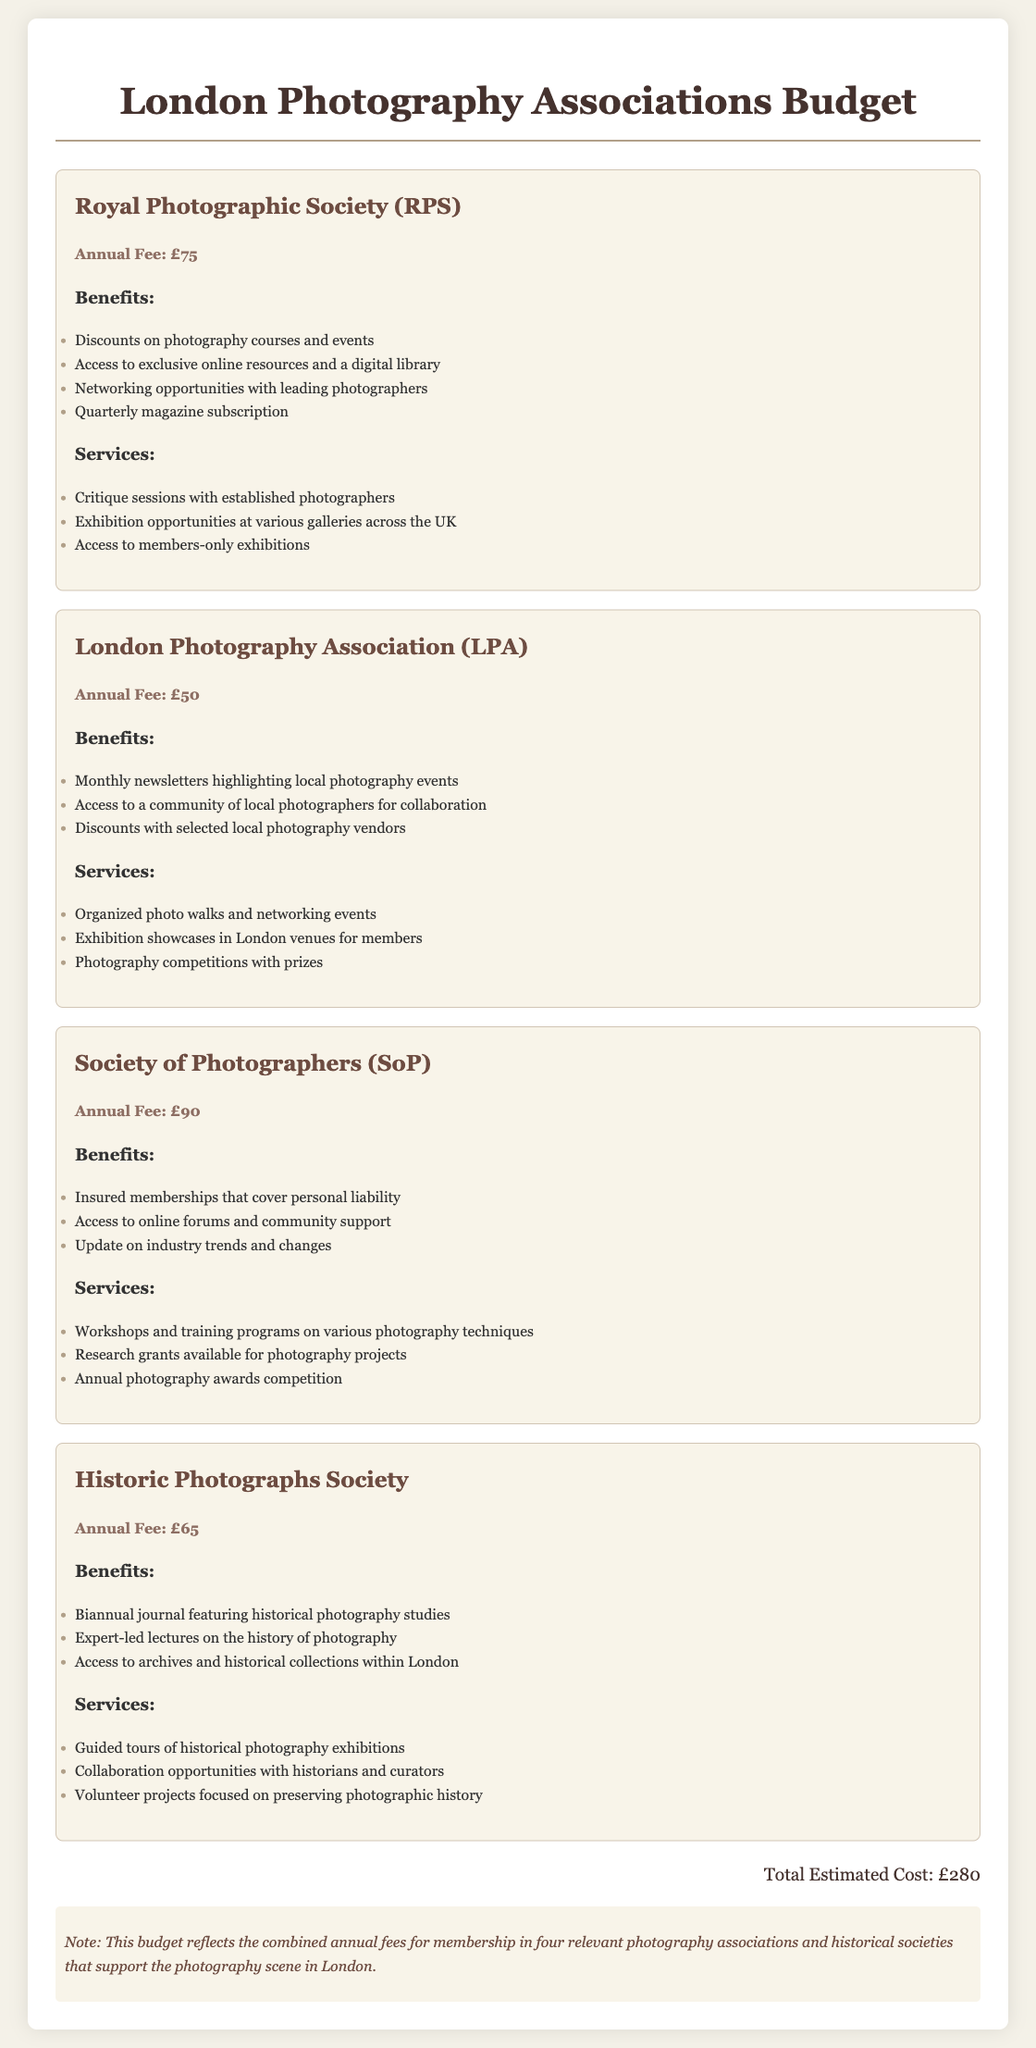What is the annual fee for the Royal Photographic Society? The document provides the annual fee for each association, which for the Royal Photographic Society is £75.
Answer: £75 What benefits does the London Photography Association offer? The benefits listed for the London Photography Association include monthly newsletters, access to a community, and discounts.
Answer: Monthly newsletters highlighting local photography events How many associations are included in the total estimated cost? The document lists four associations and sums their fees, leading to the total estimated cost.
Answer: Four What is the total estimated cost of memberships? The total estimated cost is calculated by adding the annual fees from each association listed in the document.
Answer: £280 What services are provided by the Society of Photographers? The document outlines various services offered, including workshops and research grants, particularly for the Society of Photographers.
Answer: Workshops and training programs on various photography techniques Which association offers access to historical collections within London? The benefits section for the Historic Photographs Society specifies access to historical collections within London.
Answer: Historic Photographs Society What is one benefit of joining the Society of Photographers? One of the benefits listed for the Society of Photographers includes having insured memberships that cover personal liability.
Answer: Insured memberships that cover personal liability How often is the journal published by the Historic Photographs Society? The document mentions that the journal is biannual, indicating it is published twice a year.
Answer: Biannual 